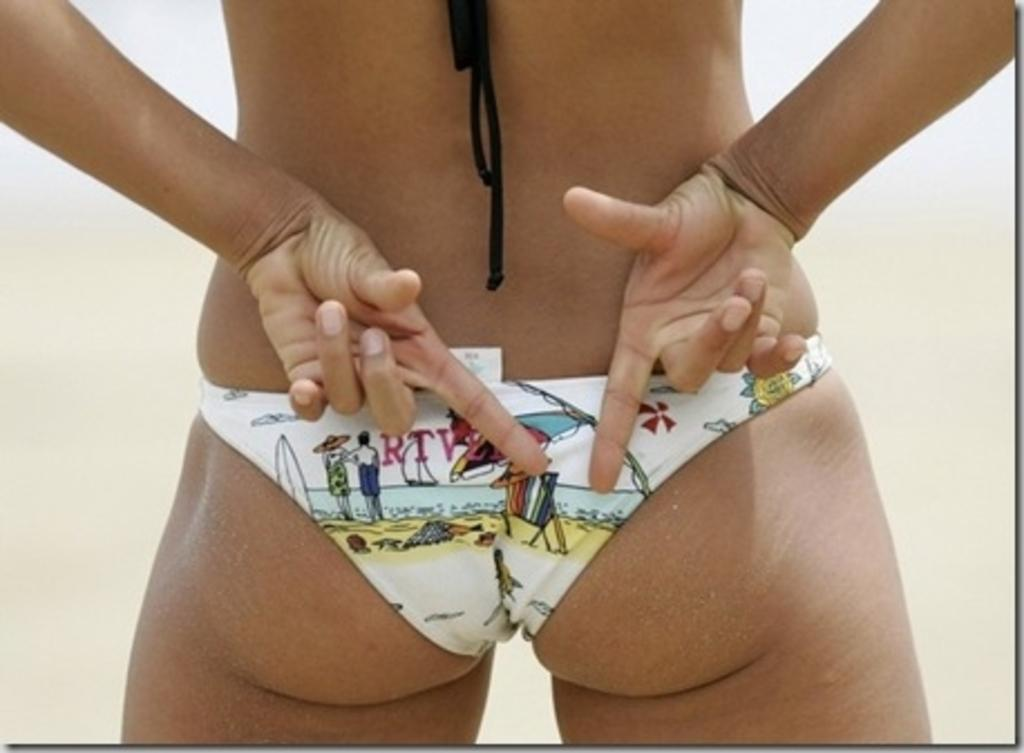What is the main subject of the image? There is a person in the image. What is the person wearing in the image? The person is wearing an undergarment. Can you describe any specific body parts of the person that are visible in the image? The fingers of the person are visible in the image. What are the fingers doing in the image? The fingers are showing a sign. What type of punishment is being depicted in the image? There is no punishment being depicted in the image; it features a person with visible fingers showing a sign. 